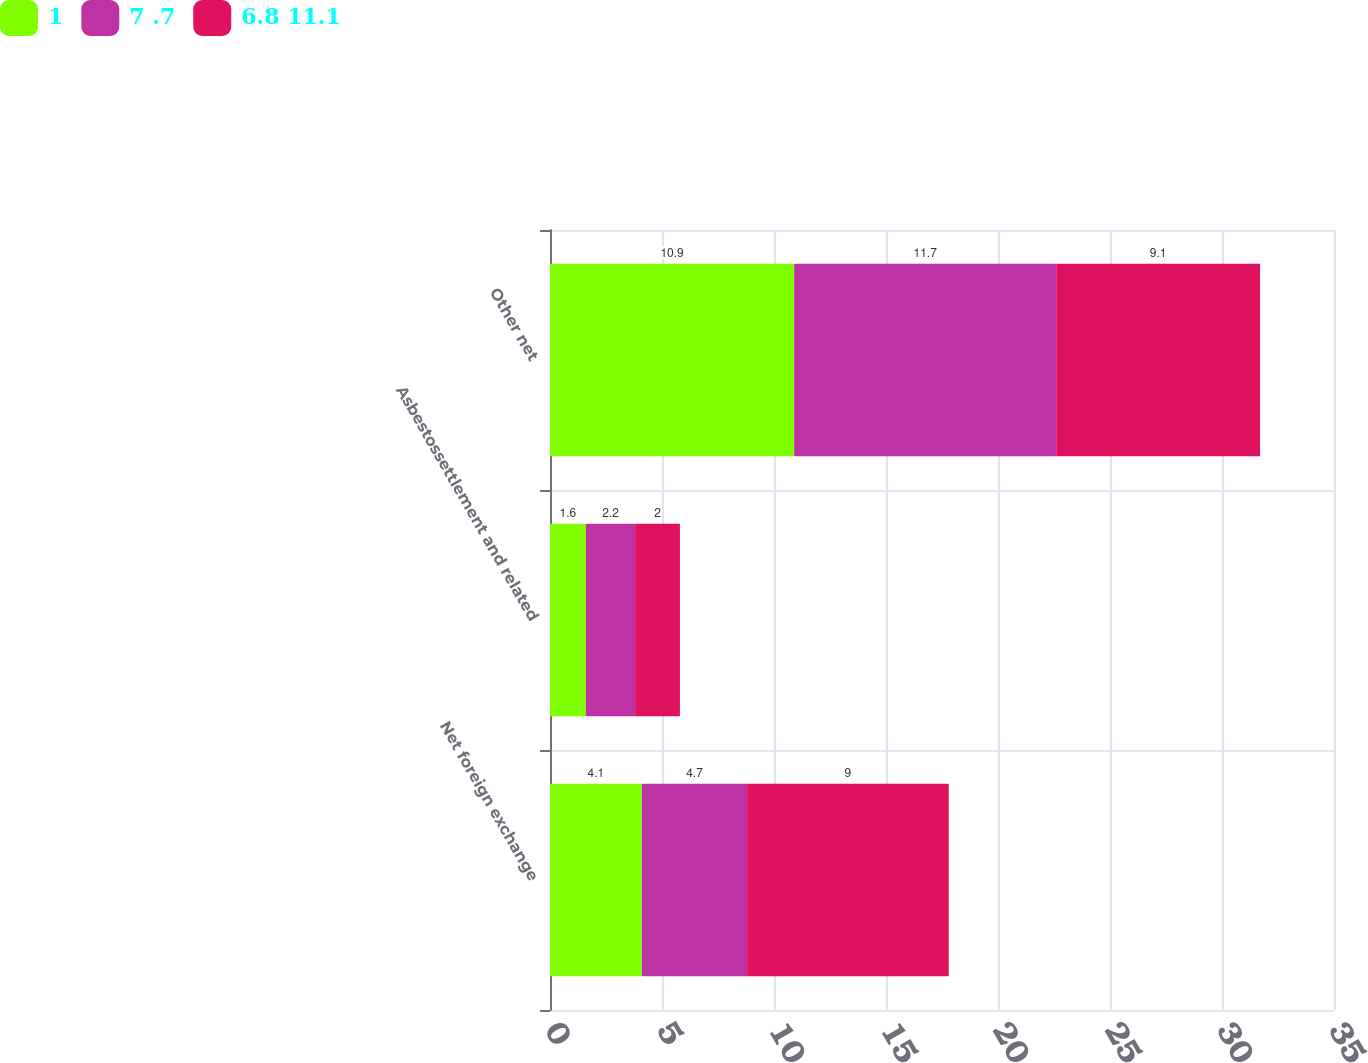Convert chart. <chart><loc_0><loc_0><loc_500><loc_500><stacked_bar_chart><ecel><fcel>Net foreign exchange<fcel>Asbestossettlement and related<fcel>Other net<nl><fcel>1<fcel>4.1<fcel>1.6<fcel>10.9<nl><fcel>7 .7<fcel>4.7<fcel>2.2<fcel>11.7<nl><fcel>6.8 11.1<fcel>9<fcel>2<fcel>9.1<nl></chart> 